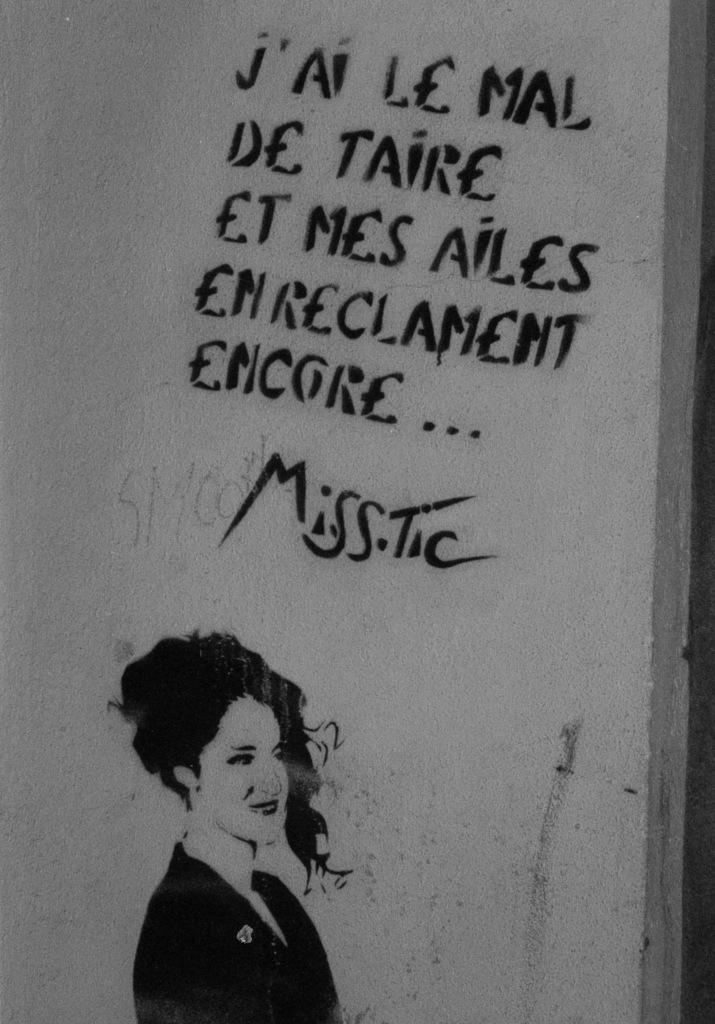What is shown on the wall in the image? There is a person depicted on the wall. What else can be seen on the wall besides the person? There is text written on the wall. What color is the wall in the image? The wall is in an ash color. Is there a stove visible in the image? No, there is no stove present in the image. What type of pot is being used to cook in the image? There is no pot or cooking activity depicted in the image. 